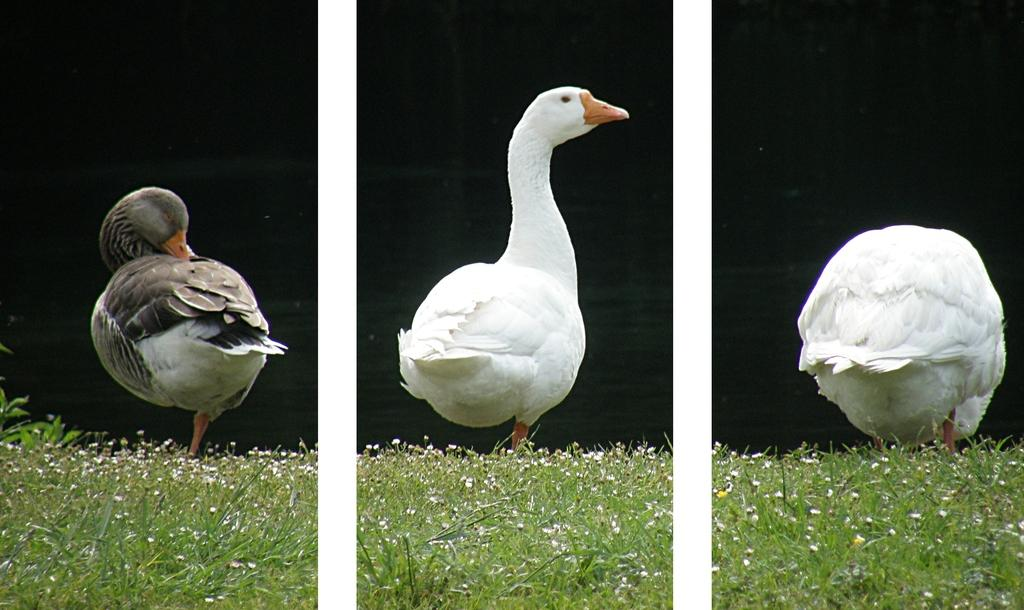What type of artwork is the image? The image is a collage. How many birds are present in the image? There are three birds in the image. What is the birds standing on in the image? The birds are standing on grass in the image. What is the color of the background in the image? The background of the image is dark. What type of horn can be seen in the image? There is no horn present in the image; it features a collage of three birds standing on grass with a dark background. What unit of measurement is used to determine the size of the birds in the image? The size of the birds in the image cannot be determined by a unit of measurement, as the image is a collage and not a photograph or illustration with a known scale. 